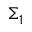Convert formula to latex. <formula><loc_0><loc_0><loc_500><loc_500>\Sigma _ { 1 }</formula> 